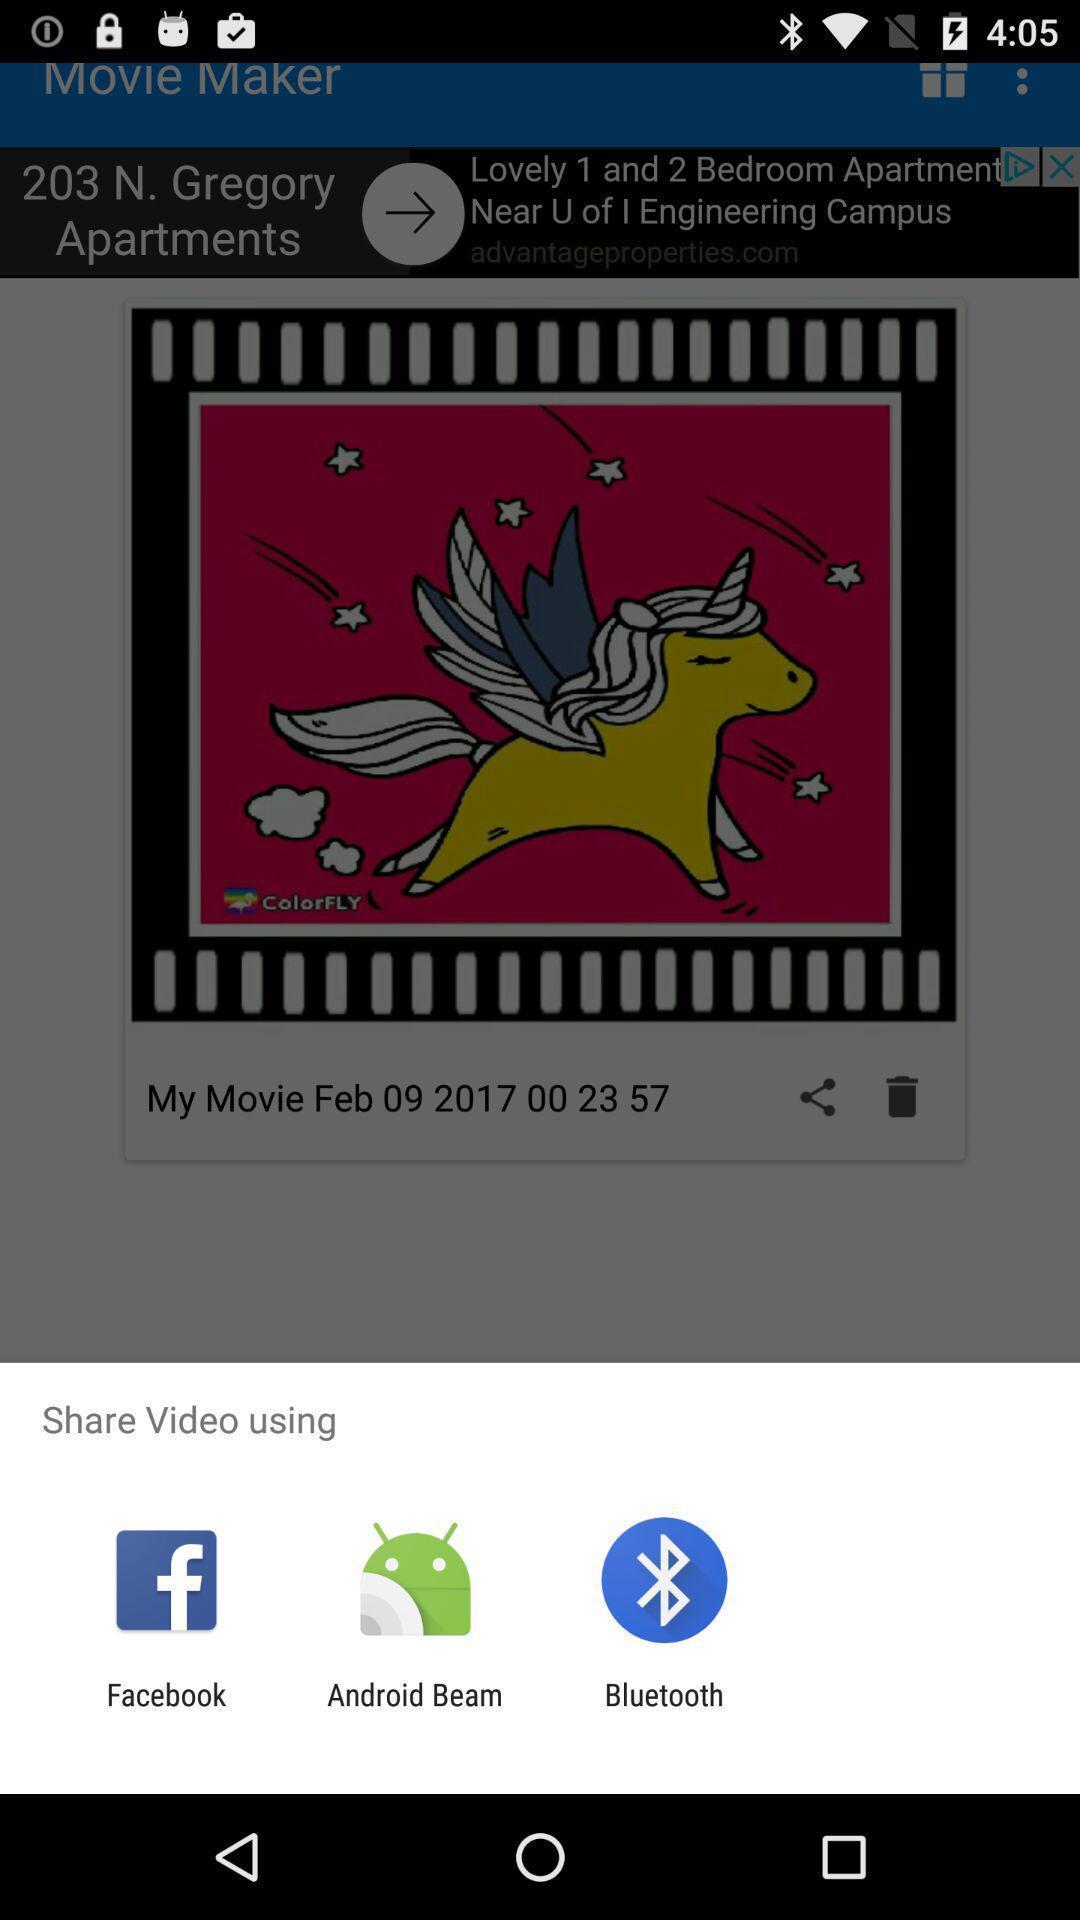Describe the content in this image. Popup showing options to share. 